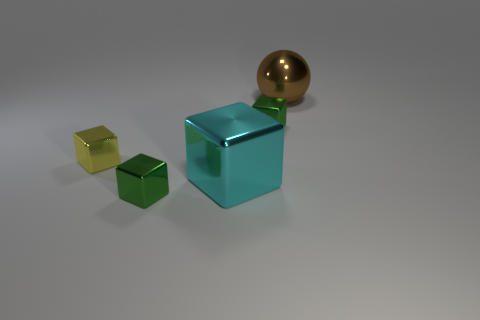Add 2 tiny purple metallic cylinders. How many objects exist? 7 Subtract all spheres. How many objects are left? 4 Subtract all small things. Subtract all small yellow objects. How many objects are left? 1 Add 4 yellow objects. How many yellow objects are left? 5 Add 5 tiny green things. How many tiny green things exist? 7 Subtract 0 green cylinders. How many objects are left? 5 